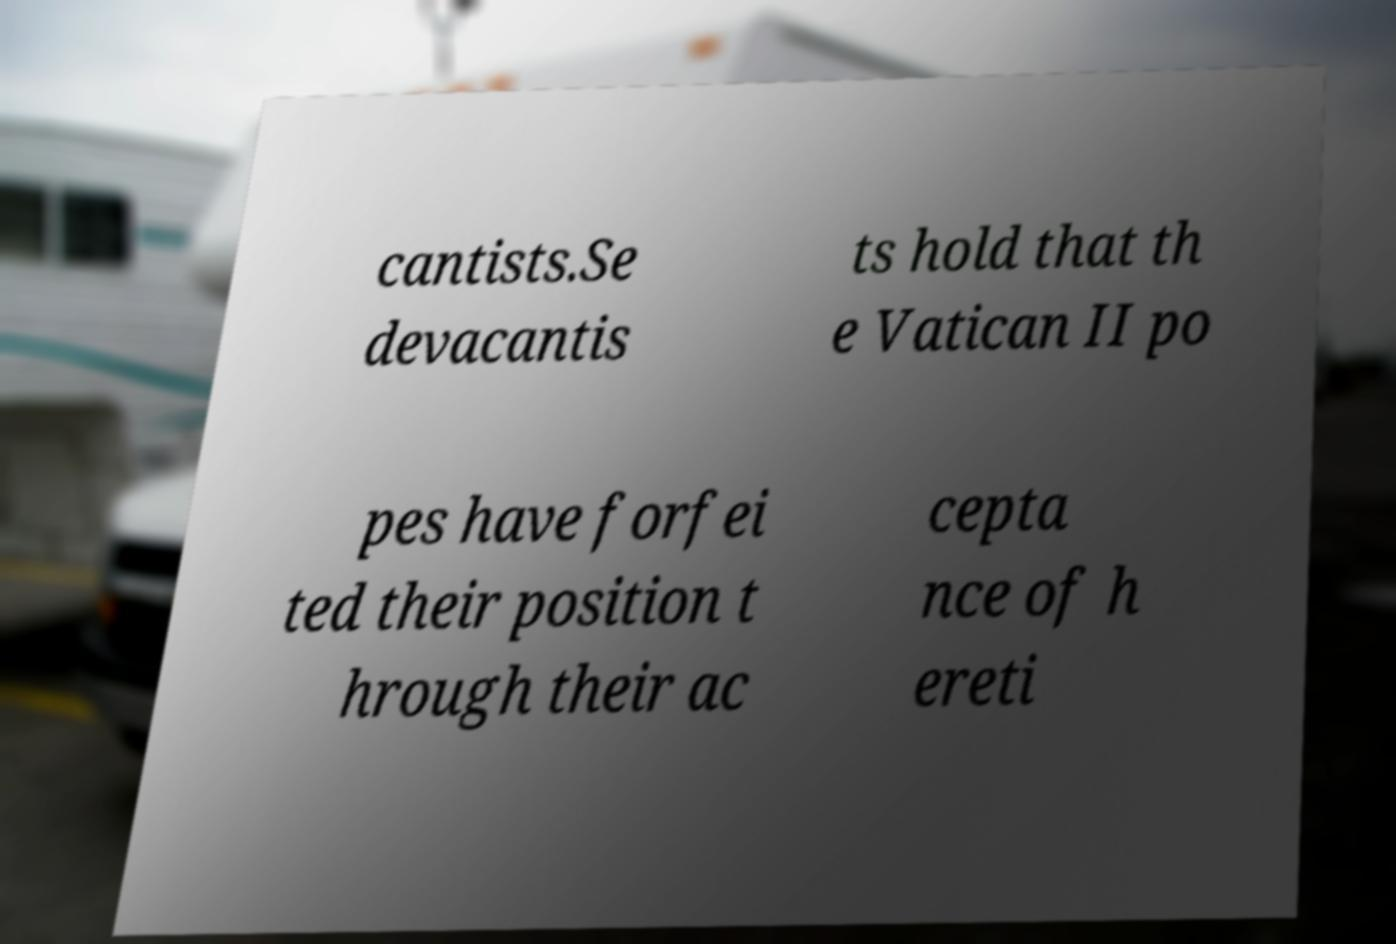Can you read and provide the text displayed in the image?This photo seems to have some interesting text. Can you extract and type it out for me? cantists.Se devacantis ts hold that th e Vatican II po pes have forfei ted their position t hrough their ac cepta nce of h ereti 